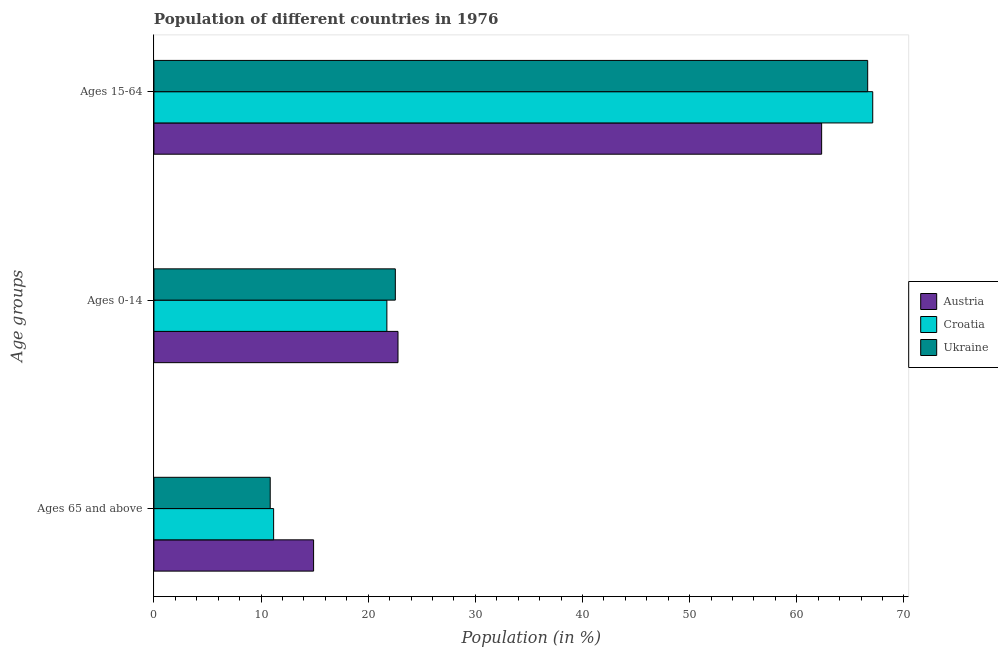How many different coloured bars are there?
Your answer should be compact. 3. How many groups of bars are there?
Your answer should be compact. 3. Are the number of bars per tick equal to the number of legend labels?
Provide a short and direct response. Yes. Are the number of bars on each tick of the Y-axis equal?
Your answer should be compact. Yes. How many bars are there on the 3rd tick from the bottom?
Keep it short and to the point. 3. What is the label of the 1st group of bars from the top?
Provide a succinct answer. Ages 15-64. What is the percentage of population within the age-group 0-14 in Croatia?
Your response must be concise. 21.74. Across all countries, what is the maximum percentage of population within the age-group 15-64?
Make the answer very short. 67.09. Across all countries, what is the minimum percentage of population within the age-group 0-14?
Make the answer very short. 21.74. What is the total percentage of population within the age-group 15-64 in the graph?
Keep it short and to the point. 196.02. What is the difference between the percentage of population within the age-group 15-64 in Ukraine and that in Croatia?
Keep it short and to the point. -0.47. What is the difference between the percentage of population within the age-group of 65 and above in Ukraine and the percentage of population within the age-group 0-14 in Austria?
Your answer should be compact. -11.93. What is the average percentage of population within the age-group 15-64 per country?
Offer a terse response. 65.34. What is the difference between the percentage of population within the age-group 0-14 and percentage of population within the age-group of 65 and above in Austria?
Your answer should be compact. 7.88. In how many countries, is the percentage of population within the age-group 15-64 greater than 50 %?
Your answer should be very brief. 3. What is the ratio of the percentage of population within the age-group 0-14 in Austria to that in Croatia?
Your answer should be very brief. 1.05. Is the percentage of population within the age-group 0-14 in Croatia less than that in Austria?
Your answer should be very brief. Yes. What is the difference between the highest and the second highest percentage of population within the age-group 15-64?
Your response must be concise. 0.47. What is the difference between the highest and the lowest percentage of population within the age-group 0-14?
Provide a succinct answer. 1.04. Is the sum of the percentage of population within the age-group 0-14 in Croatia and Austria greater than the maximum percentage of population within the age-group 15-64 across all countries?
Keep it short and to the point. No. What does the 3rd bar from the top in Ages 65 and above represents?
Keep it short and to the point. Austria. What does the 2nd bar from the bottom in Ages 15-64 represents?
Your answer should be compact. Croatia. Is it the case that in every country, the sum of the percentage of population within the age-group of 65 and above and percentage of population within the age-group 0-14 is greater than the percentage of population within the age-group 15-64?
Offer a terse response. No. How many bars are there?
Make the answer very short. 9. How many countries are there in the graph?
Provide a succinct answer. 3. What is the difference between two consecutive major ticks on the X-axis?
Offer a terse response. 10. Are the values on the major ticks of X-axis written in scientific E-notation?
Ensure brevity in your answer.  No. Does the graph contain any zero values?
Your answer should be very brief. No. How are the legend labels stacked?
Make the answer very short. Vertical. What is the title of the graph?
Offer a terse response. Population of different countries in 1976. Does "Vietnam" appear as one of the legend labels in the graph?
Ensure brevity in your answer.  No. What is the label or title of the X-axis?
Make the answer very short. Population (in %). What is the label or title of the Y-axis?
Your answer should be compact. Age groups. What is the Population (in %) in Austria in Ages 65 and above?
Ensure brevity in your answer.  14.9. What is the Population (in %) in Croatia in Ages 65 and above?
Keep it short and to the point. 11.17. What is the Population (in %) in Ukraine in Ages 65 and above?
Your response must be concise. 10.85. What is the Population (in %) in Austria in Ages 0-14?
Your answer should be very brief. 22.78. What is the Population (in %) in Croatia in Ages 0-14?
Your answer should be compact. 21.74. What is the Population (in %) of Ukraine in Ages 0-14?
Offer a terse response. 22.53. What is the Population (in %) in Austria in Ages 15-64?
Offer a very short reply. 62.32. What is the Population (in %) of Croatia in Ages 15-64?
Provide a succinct answer. 67.09. What is the Population (in %) of Ukraine in Ages 15-64?
Your answer should be very brief. 66.62. Across all Age groups, what is the maximum Population (in %) of Austria?
Provide a succinct answer. 62.32. Across all Age groups, what is the maximum Population (in %) of Croatia?
Offer a very short reply. 67.09. Across all Age groups, what is the maximum Population (in %) in Ukraine?
Your answer should be compact. 66.62. Across all Age groups, what is the minimum Population (in %) in Austria?
Offer a terse response. 14.9. Across all Age groups, what is the minimum Population (in %) in Croatia?
Offer a terse response. 11.17. Across all Age groups, what is the minimum Population (in %) of Ukraine?
Make the answer very short. 10.85. What is the total Population (in %) of Austria in the graph?
Your answer should be very brief. 100. What is the total Population (in %) in Croatia in the graph?
Keep it short and to the point. 100. What is the total Population (in %) in Ukraine in the graph?
Your answer should be very brief. 100. What is the difference between the Population (in %) of Austria in Ages 65 and above and that in Ages 0-14?
Make the answer very short. -7.88. What is the difference between the Population (in %) of Croatia in Ages 65 and above and that in Ages 0-14?
Ensure brevity in your answer.  -10.57. What is the difference between the Population (in %) of Ukraine in Ages 65 and above and that in Ages 0-14?
Offer a very short reply. -11.68. What is the difference between the Population (in %) of Austria in Ages 65 and above and that in Ages 15-64?
Make the answer very short. -47.42. What is the difference between the Population (in %) of Croatia in Ages 65 and above and that in Ages 15-64?
Ensure brevity in your answer.  -55.92. What is the difference between the Population (in %) in Ukraine in Ages 65 and above and that in Ages 15-64?
Your answer should be very brief. -55.76. What is the difference between the Population (in %) of Austria in Ages 0-14 and that in Ages 15-64?
Provide a succinct answer. -39.54. What is the difference between the Population (in %) of Croatia in Ages 0-14 and that in Ages 15-64?
Provide a short and direct response. -45.35. What is the difference between the Population (in %) of Ukraine in Ages 0-14 and that in Ages 15-64?
Keep it short and to the point. -44.09. What is the difference between the Population (in %) of Austria in Ages 65 and above and the Population (in %) of Croatia in Ages 0-14?
Give a very brief answer. -6.84. What is the difference between the Population (in %) of Austria in Ages 65 and above and the Population (in %) of Ukraine in Ages 0-14?
Your answer should be very brief. -7.63. What is the difference between the Population (in %) of Croatia in Ages 65 and above and the Population (in %) of Ukraine in Ages 0-14?
Ensure brevity in your answer.  -11.36. What is the difference between the Population (in %) of Austria in Ages 65 and above and the Population (in %) of Croatia in Ages 15-64?
Offer a very short reply. -52.19. What is the difference between the Population (in %) of Austria in Ages 65 and above and the Population (in %) of Ukraine in Ages 15-64?
Provide a succinct answer. -51.71. What is the difference between the Population (in %) of Croatia in Ages 65 and above and the Population (in %) of Ukraine in Ages 15-64?
Provide a succinct answer. -55.44. What is the difference between the Population (in %) in Austria in Ages 0-14 and the Population (in %) in Croatia in Ages 15-64?
Give a very brief answer. -44.31. What is the difference between the Population (in %) of Austria in Ages 0-14 and the Population (in %) of Ukraine in Ages 15-64?
Provide a short and direct response. -43.84. What is the difference between the Population (in %) of Croatia in Ages 0-14 and the Population (in %) of Ukraine in Ages 15-64?
Your answer should be compact. -44.87. What is the average Population (in %) of Austria per Age groups?
Your answer should be compact. 33.33. What is the average Population (in %) in Croatia per Age groups?
Give a very brief answer. 33.33. What is the average Population (in %) of Ukraine per Age groups?
Your answer should be compact. 33.33. What is the difference between the Population (in %) in Austria and Population (in %) in Croatia in Ages 65 and above?
Give a very brief answer. 3.73. What is the difference between the Population (in %) of Austria and Population (in %) of Ukraine in Ages 65 and above?
Offer a terse response. 4.05. What is the difference between the Population (in %) of Croatia and Population (in %) of Ukraine in Ages 65 and above?
Your response must be concise. 0.32. What is the difference between the Population (in %) in Austria and Population (in %) in Croatia in Ages 0-14?
Offer a very short reply. 1.04. What is the difference between the Population (in %) of Austria and Population (in %) of Ukraine in Ages 0-14?
Your answer should be very brief. 0.25. What is the difference between the Population (in %) in Croatia and Population (in %) in Ukraine in Ages 0-14?
Provide a succinct answer. -0.79. What is the difference between the Population (in %) of Austria and Population (in %) of Croatia in Ages 15-64?
Keep it short and to the point. -4.77. What is the difference between the Population (in %) in Austria and Population (in %) in Ukraine in Ages 15-64?
Offer a very short reply. -4.3. What is the difference between the Population (in %) of Croatia and Population (in %) of Ukraine in Ages 15-64?
Your answer should be very brief. 0.47. What is the ratio of the Population (in %) of Austria in Ages 65 and above to that in Ages 0-14?
Make the answer very short. 0.65. What is the ratio of the Population (in %) in Croatia in Ages 65 and above to that in Ages 0-14?
Keep it short and to the point. 0.51. What is the ratio of the Population (in %) in Ukraine in Ages 65 and above to that in Ages 0-14?
Your answer should be compact. 0.48. What is the ratio of the Population (in %) in Austria in Ages 65 and above to that in Ages 15-64?
Provide a short and direct response. 0.24. What is the ratio of the Population (in %) of Croatia in Ages 65 and above to that in Ages 15-64?
Keep it short and to the point. 0.17. What is the ratio of the Population (in %) in Ukraine in Ages 65 and above to that in Ages 15-64?
Keep it short and to the point. 0.16. What is the ratio of the Population (in %) in Austria in Ages 0-14 to that in Ages 15-64?
Give a very brief answer. 0.37. What is the ratio of the Population (in %) of Croatia in Ages 0-14 to that in Ages 15-64?
Your response must be concise. 0.32. What is the ratio of the Population (in %) in Ukraine in Ages 0-14 to that in Ages 15-64?
Keep it short and to the point. 0.34. What is the difference between the highest and the second highest Population (in %) of Austria?
Provide a succinct answer. 39.54. What is the difference between the highest and the second highest Population (in %) of Croatia?
Provide a succinct answer. 45.35. What is the difference between the highest and the second highest Population (in %) of Ukraine?
Your answer should be very brief. 44.09. What is the difference between the highest and the lowest Population (in %) of Austria?
Offer a terse response. 47.42. What is the difference between the highest and the lowest Population (in %) of Croatia?
Provide a short and direct response. 55.92. What is the difference between the highest and the lowest Population (in %) in Ukraine?
Your answer should be compact. 55.76. 